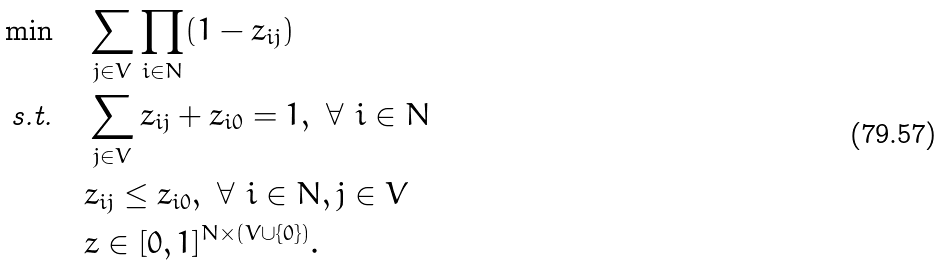<formula> <loc_0><loc_0><loc_500><loc_500>\min & \quad \sum _ { j \in V } \prod _ { i \in N } ( 1 - z _ { i j } ) \\ \text {s.t.} & \quad \sum _ { j \in V } z _ { i j } + z _ { i 0 } = 1 , \ \forall \ i \in N \\ & \quad z _ { i j } \leq z _ { i 0 } , \ \forall \ i \in N , j \in V \\ & \quad z \in [ 0 , 1 ] ^ { N \times ( V \cup \{ 0 \} ) } .</formula> 